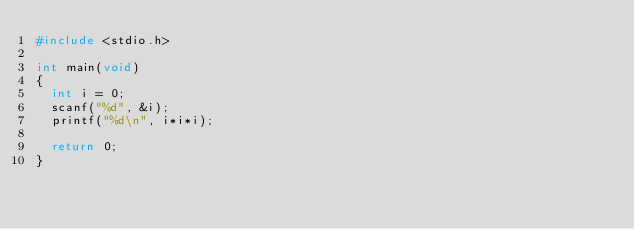<code> <loc_0><loc_0><loc_500><loc_500><_C_>#include <stdio.h>

int main(void)
{
	int i = 0;
	scanf("%d", &i);
	printf("%d\n", i*i*i);

	return 0;
}
</code> 